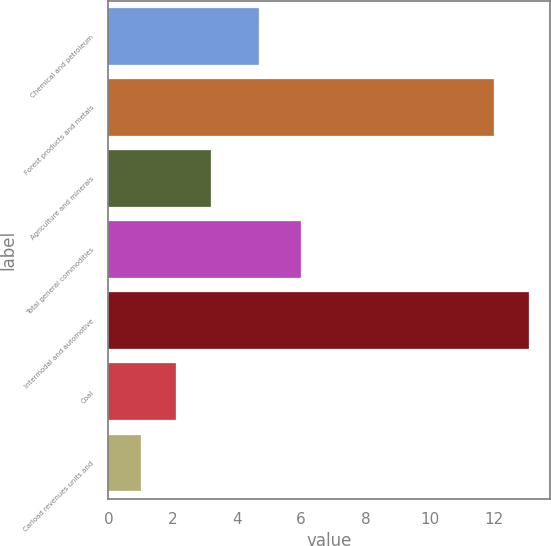Convert chart. <chart><loc_0><loc_0><loc_500><loc_500><bar_chart><fcel>Chemical and petroleum<fcel>Forest products and metals<fcel>Agriculture and minerals<fcel>Total general commodities<fcel>Intermodal and automotive<fcel>Coal<fcel>Carload revenues units and<nl><fcel>4.68<fcel>12<fcel>3.2<fcel>6<fcel>13.1<fcel>2.1<fcel>1<nl></chart> 